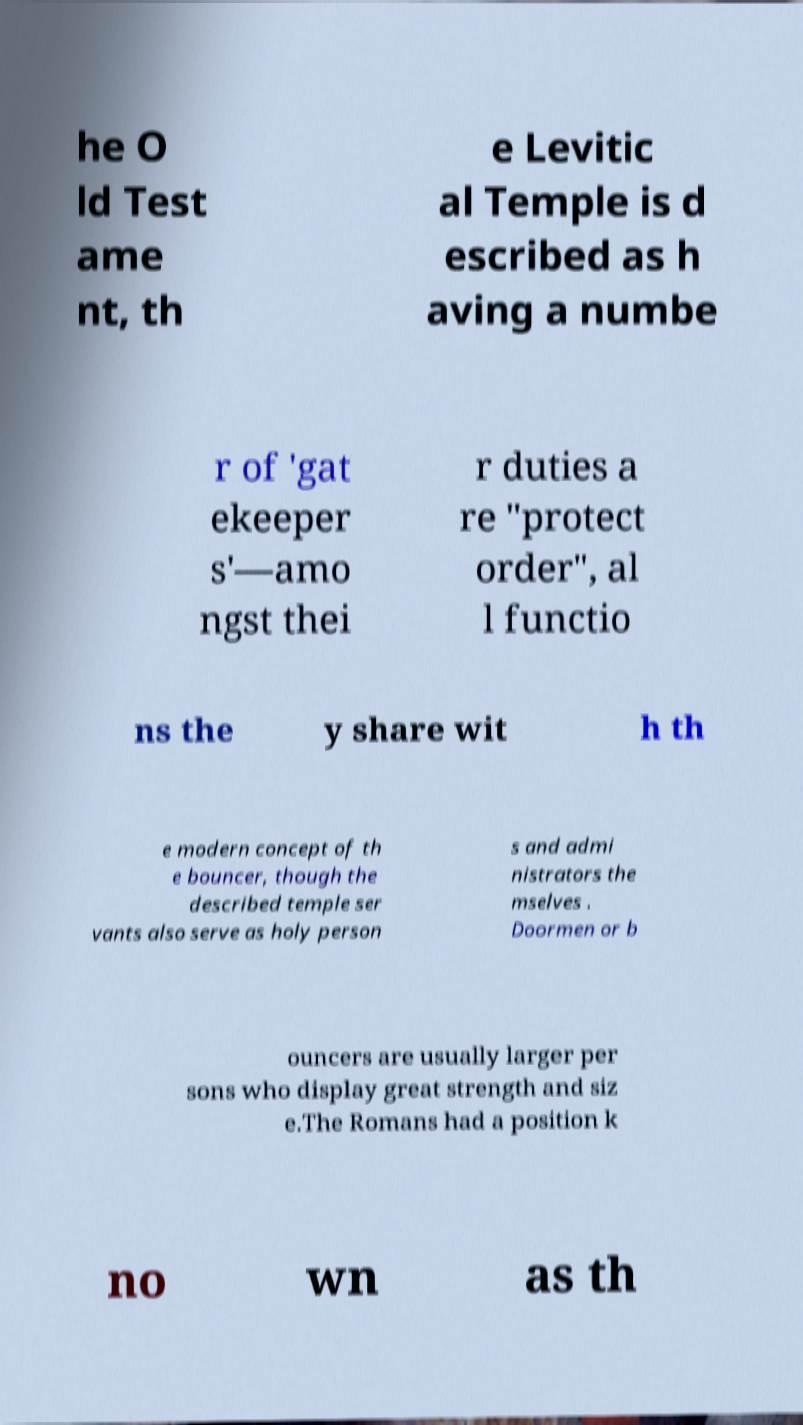I need the written content from this picture converted into text. Can you do that? he O ld Test ame nt, th e Levitic al Temple is d escribed as h aving a numbe r of 'gat ekeeper s'—amo ngst thei r duties a re "protect order", al l functio ns the y share wit h th e modern concept of th e bouncer, though the described temple ser vants also serve as holy person s and admi nistrators the mselves . Doormen or b ouncers are usually larger per sons who display great strength and siz e.The Romans had a position k no wn as th 